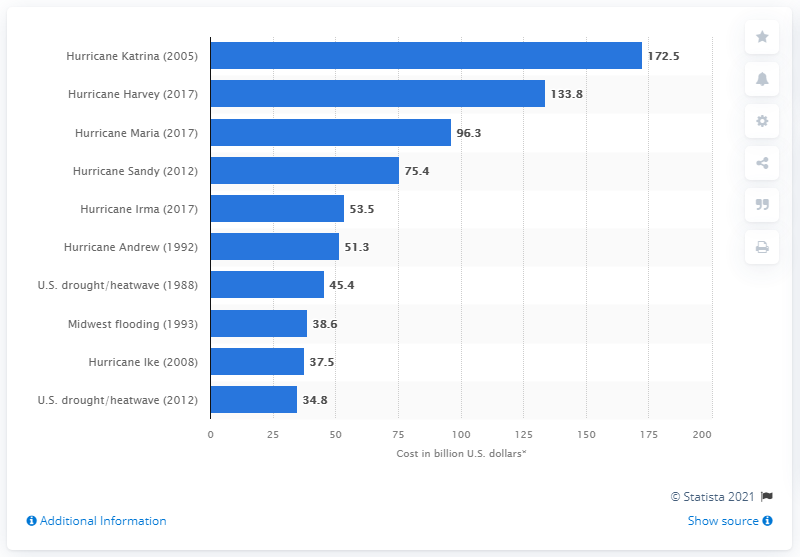Point out several critical features in this image. According to current estimates, the cost of Hurricane Katrina in 2021 is approximately 172.5 billion dollars. Hurricane Harvey cost an estimated 133.8 billion dollars in 2021. 